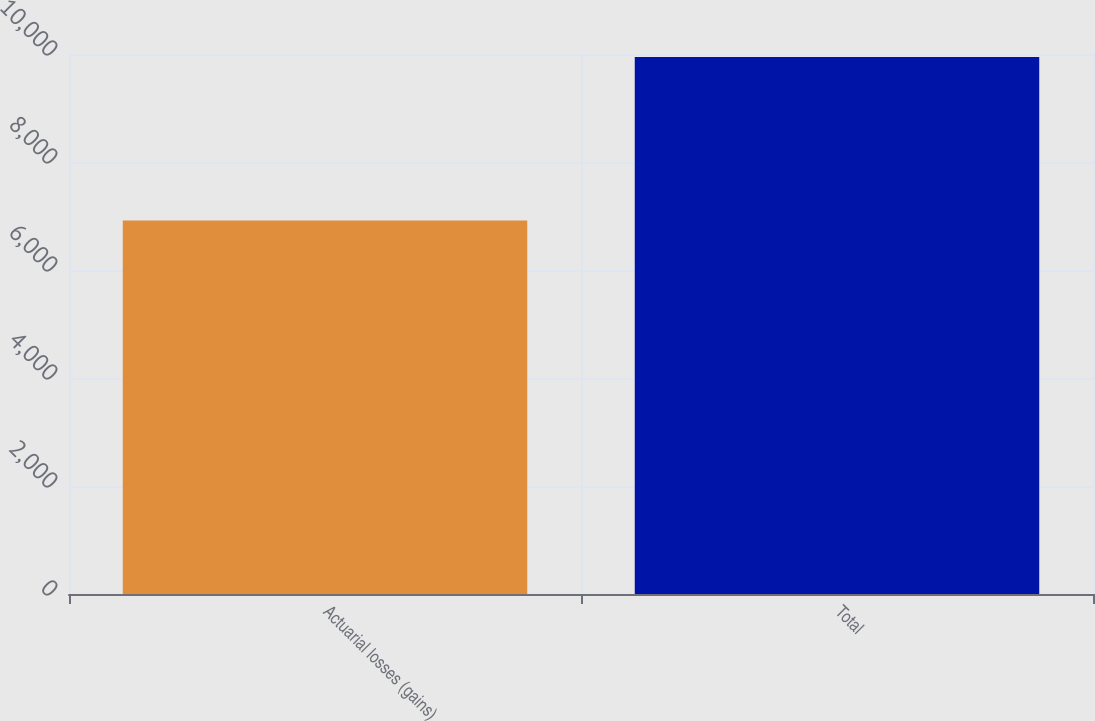<chart> <loc_0><loc_0><loc_500><loc_500><bar_chart><fcel>Actuarial losses (gains)<fcel>Total<nl><fcel>6915<fcel>9943<nl></chart> 